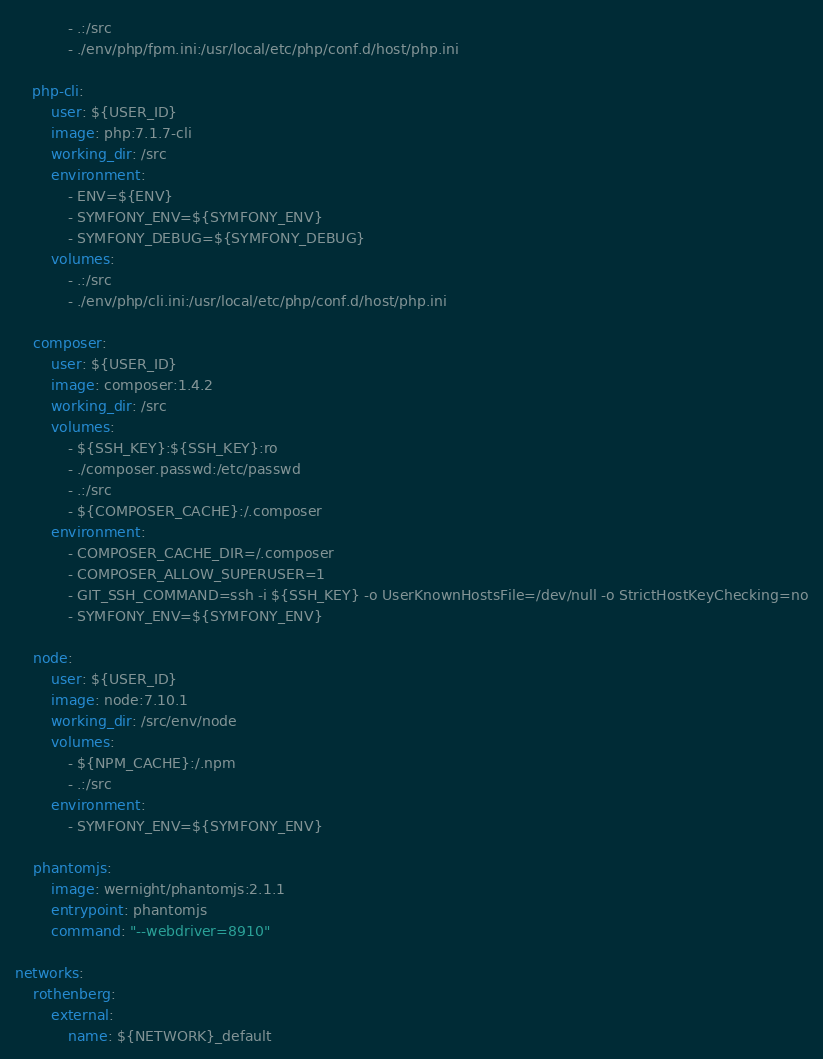<code> <loc_0><loc_0><loc_500><loc_500><_YAML_>            - .:/src
            - ./env/php/fpm.ini:/usr/local/etc/php/conf.d/host/php.ini

    php-cli:
        user: ${USER_ID}
        image: php:7.1.7-cli
        working_dir: /src
        environment:
            - ENV=${ENV}
            - SYMFONY_ENV=${SYMFONY_ENV}
            - SYMFONY_DEBUG=${SYMFONY_DEBUG}
        volumes:
            - .:/src
            - ./env/php/cli.ini:/usr/local/etc/php/conf.d/host/php.ini

    composer:
        user: ${USER_ID}
        image: composer:1.4.2
        working_dir: /src
        volumes:
            - ${SSH_KEY}:${SSH_KEY}:ro
            - ./composer.passwd:/etc/passwd
            - .:/src
            - ${COMPOSER_CACHE}:/.composer
        environment:
            - COMPOSER_CACHE_DIR=/.composer
            - COMPOSER_ALLOW_SUPERUSER=1
            - GIT_SSH_COMMAND=ssh -i ${SSH_KEY} -o UserKnownHostsFile=/dev/null -o StrictHostKeyChecking=no
            - SYMFONY_ENV=${SYMFONY_ENV}

    node:
        user: ${USER_ID}
        image: node:7.10.1
        working_dir: /src/env/node
        volumes:
            - ${NPM_CACHE}:/.npm
            - .:/src
        environment:
            - SYMFONY_ENV=${SYMFONY_ENV}

    phantomjs:
        image: wernight/phantomjs:2.1.1
        entrypoint: phantomjs
        command: "--webdriver=8910"

networks:
    rothenberg:
        external:
            name: ${NETWORK}_default
</code> 